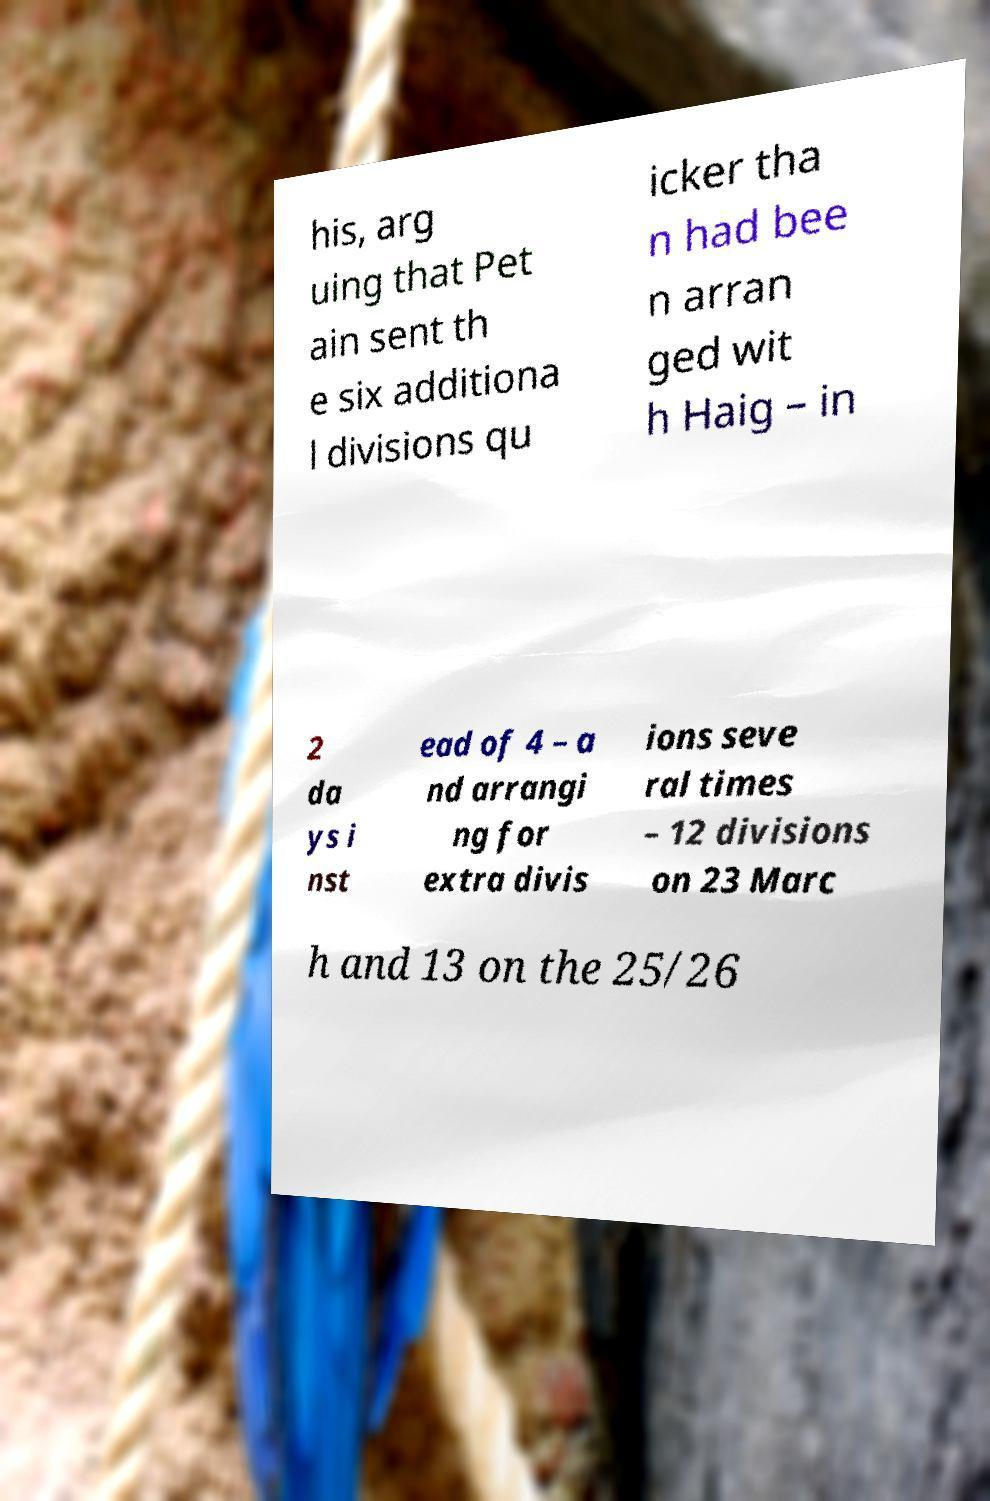I need the written content from this picture converted into text. Can you do that? his, arg uing that Pet ain sent th e six additiona l divisions qu icker tha n had bee n arran ged wit h Haig – in 2 da ys i nst ead of 4 – a nd arrangi ng for extra divis ions seve ral times – 12 divisions on 23 Marc h and 13 on the 25/26 